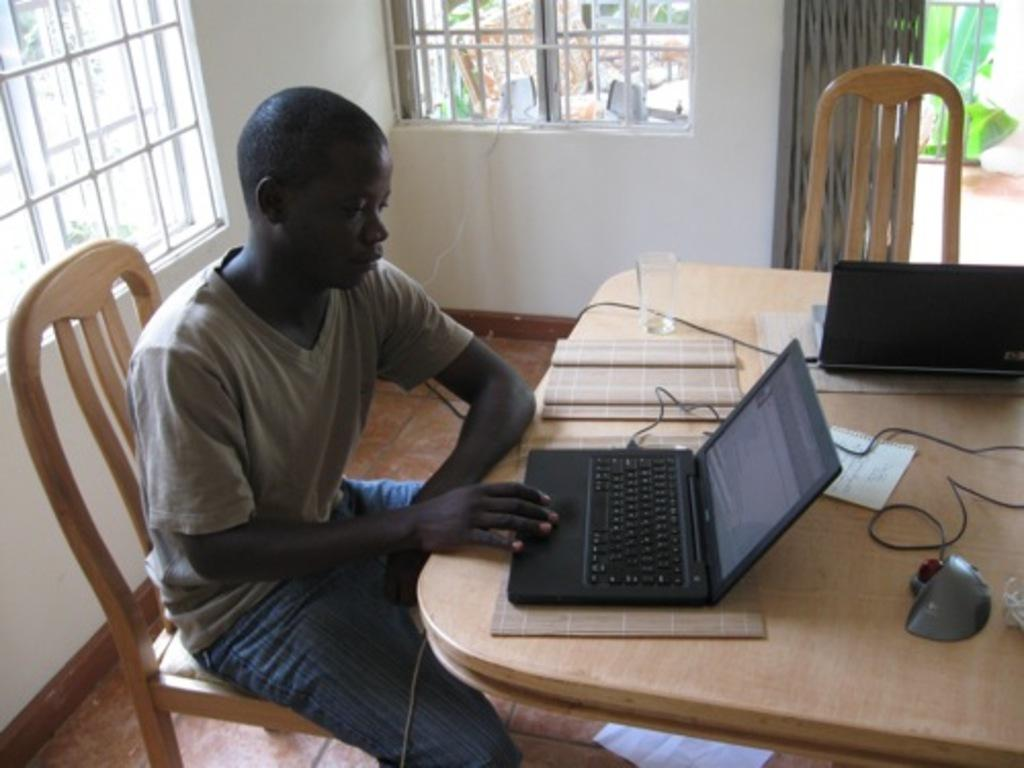What is the person in the image doing? The person is sitting on a chair and working on a laptop. What is the person using to work in the image? The person is using a laptop. Can you describe the setting where the person is working? There is a glass on a table and a window in the image. What might be the purpose of the window in the image? The window provides natural light and a view of the outside. What type of pleasure can be seen being written on the laptop in the image? There is no indication in the image that the person is writing about pleasure or any specific topic. 